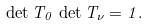<formula> <loc_0><loc_0><loc_500><loc_500>\det T _ { 0 } \, \det T _ { \nu } = 1 .</formula> 